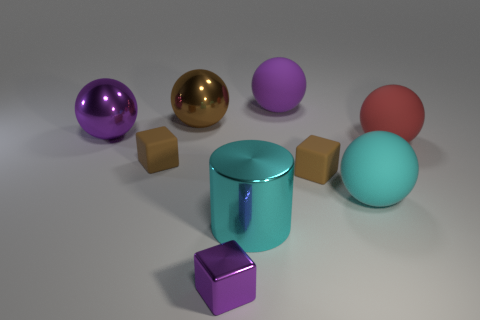The thing that is the same color as the big shiny cylinder is what size?
Your answer should be compact. Large. What number of tiny objects are either purple objects or red rubber balls?
Give a very brief answer. 1. The shiny cylinder that is the same size as the purple matte thing is what color?
Provide a succinct answer. Cyan. How many other objects are the same shape as the large brown metallic thing?
Offer a terse response. 4. Are there any large cyan spheres made of the same material as the large red sphere?
Your response must be concise. Yes. Do the large purple thing behind the brown metallic object and the tiny block that is in front of the large cyan metal cylinder have the same material?
Provide a succinct answer. No. How many small gray metal objects are there?
Offer a very short reply. 0. What shape is the purple metallic object that is behind the large cyan matte sphere?
Ensure brevity in your answer.  Sphere. What number of other things are there of the same size as the brown shiny ball?
Ensure brevity in your answer.  5. There is a tiny shiny thing that is in front of the brown metallic sphere; does it have the same shape as the tiny object that is on the left side of the metallic block?
Keep it short and to the point. Yes. 